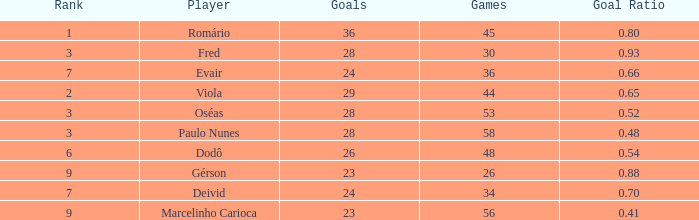How many goal ratios have rank of 2 with more than 44 games? 0.0. 